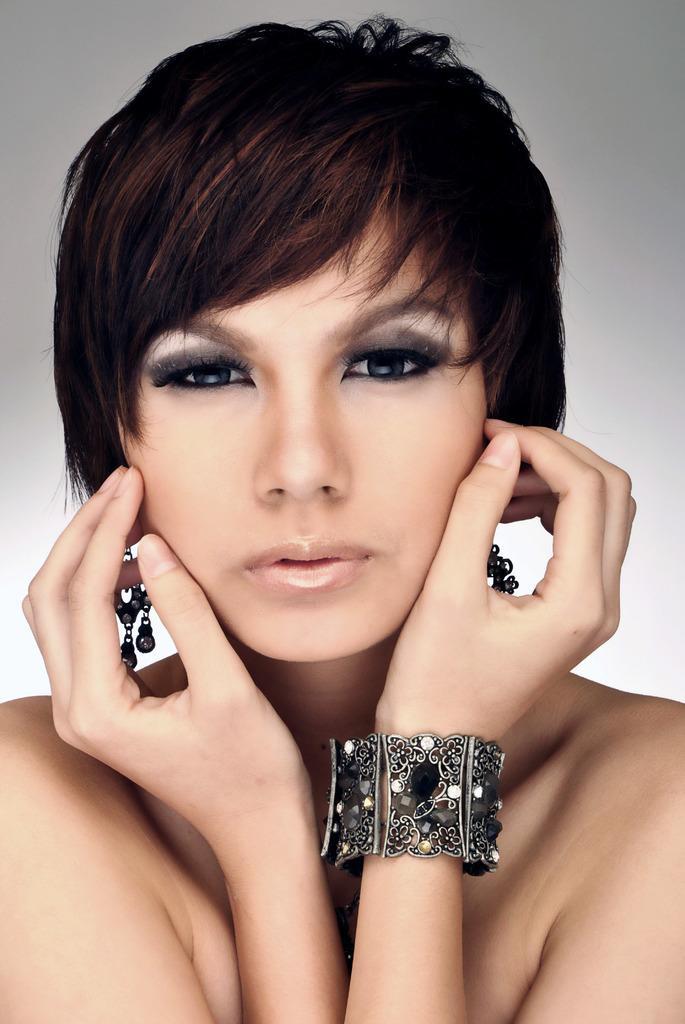Please provide a concise description of this image. In this picture we can see a woman wearing jewelry. 